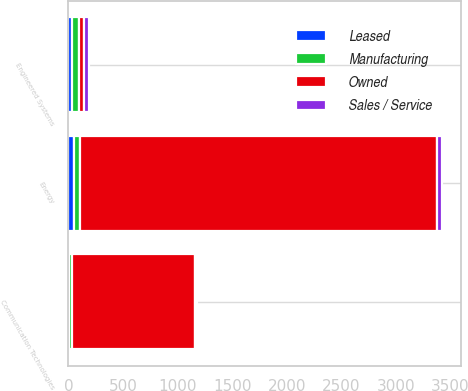<chart> <loc_0><loc_0><loc_500><loc_500><stacked_bar_chart><ecel><fcel>Communication Technologies<fcel>Energy<fcel>Engineered Systems<nl><fcel>Manufacturing<fcel>31<fcel>59<fcel>65<nl><fcel>Leased<fcel>3<fcel>51<fcel>34<nl><fcel>Sales / Service<fcel>12<fcel>47<fcel>46<nl><fcel>Owned<fcel>1129<fcel>3265<fcel>47<nl></chart> 